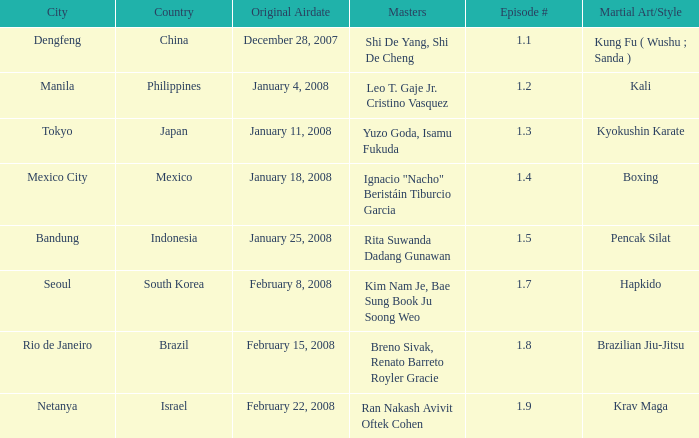Which martial arts style was shown in Rio de Janeiro? Brazilian Jiu-Jitsu. Parse the table in full. {'header': ['City', 'Country', 'Original Airdate', 'Masters', 'Episode #', 'Martial Art/Style'], 'rows': [['Dengfeng', 'China', 'December 28, 2007', 'Shi De Yang, Shi De Cheng', '1.1', 'Kung Fu ( Wushu ; Sanda )'], ['Manila', 'Philippines', 'January 4, 2008', 'Leo T. Gaje Jr. Cristino Vasquez', '1.2', 'Kali'], ['Tokyo', 'Japan', 'January 11, 2008', 'Yuzo Goda, Isamu Fukuda', '1.3', 'Kyokushin Karate'], ['Mexico City', 'Mexico', 'January 18, 2008', 'Ignacio "Nacho" Beristáin Tiburcio Garcia', '1.4', 'Boxing'], ['Bandung', 'Indonesia', 'January 25, 2008', 'Rita Suwanda Dadang Gunawan', '1.5', 'Pencak Silat'], ['Seoul', 'South Korea', 'February 8, 2008', 'Kim Nam Je, Bae Sung Book Ju Soong Weo', '1.7', 'Hapkido'], ['Rio de Janeiro', 'Brazil', 'February 15, 2008', 'Breno Sivak, Renato Barreto Royler Gracie', '1.8', 'Brazilian Jiu-Jitsu'], ['Netanya', 'Israel', 'February 22, 2008', 'Ran Nakash Avivit Oftek Cohen', '1.9', 'Krav Maga']]} 